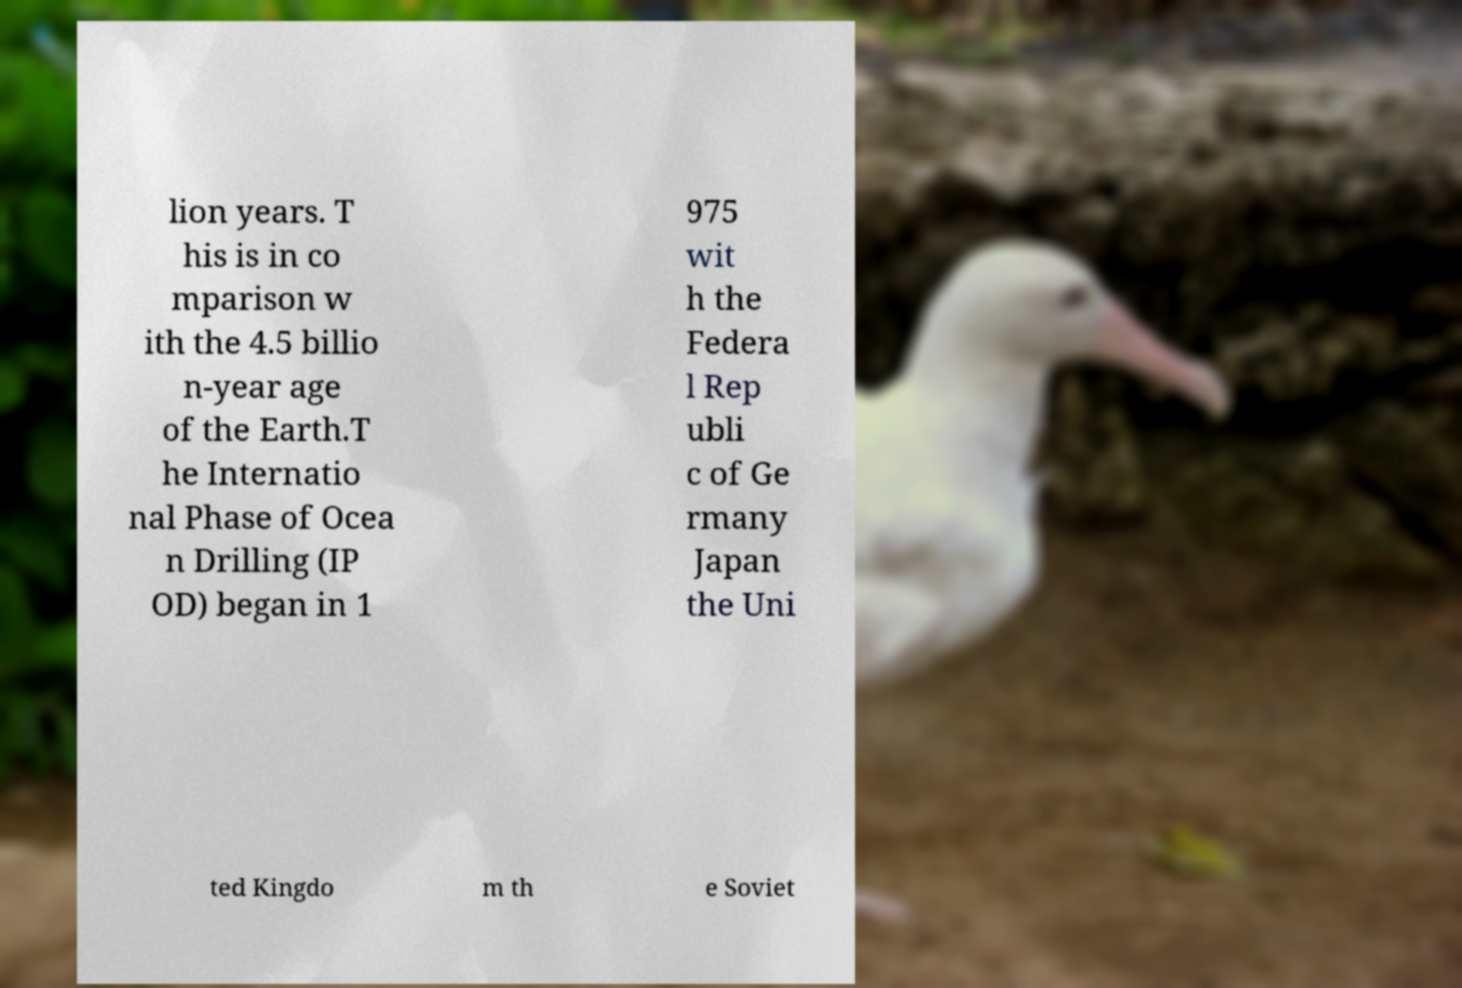I need the written content from this picture converted into text. Can you do that? lion years. T his is in co mparison w ith the 4.5 billio n-year age of the Earth.T he Internatio nal Phase of Ocea n Drilling (IP OD) began in 1 975 wit h the Federa l Rep ubli c of Ge rmany Japan the Uni ted Kingdo m th e Soviet 